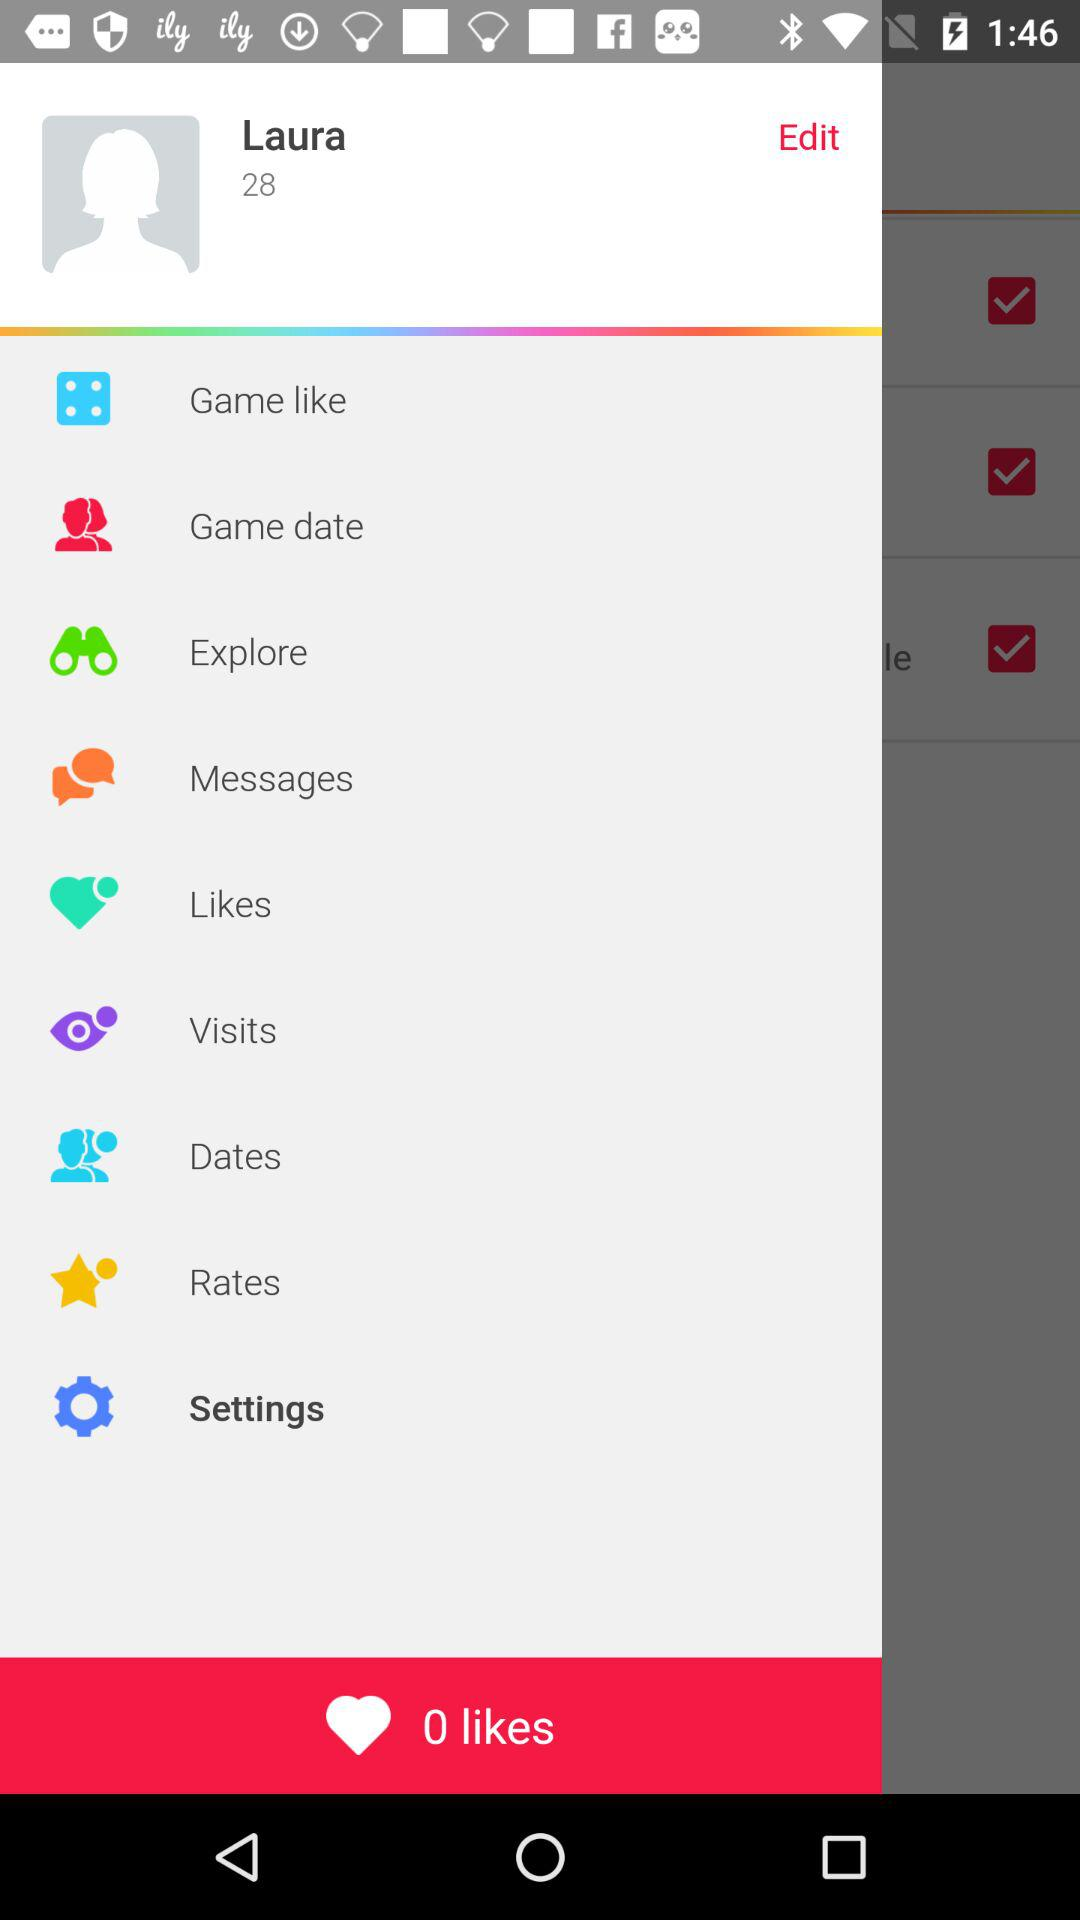What is the given user name? The given user name is Laura. 